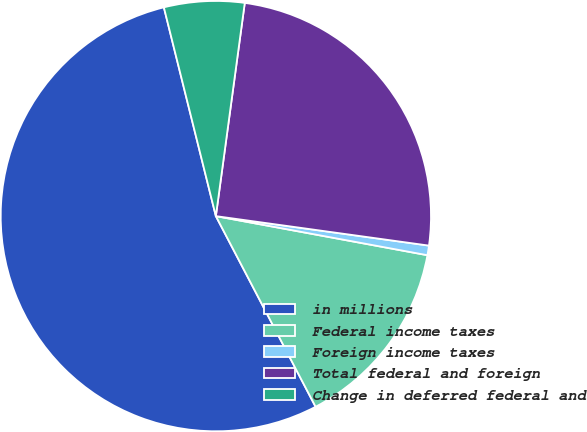<chart> <loc_0><loc_0><loc_500><loc_500><pie_chart><fcel>in millions<fcel>Federal income taxes<fcel>Foreign income taxes<fcel>Total federal and foreign<fcel>Change in deferred federal and<nl><fcel>53.78%<fcel>14.42%<fcel>0.72%<fcel>25.04%<fcel>6.03%<nl></chart> 